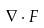Convert formula to latex. <formula><loc_0><loc_0><loc_500><loc_500>\nabla \cdot F</formula> 